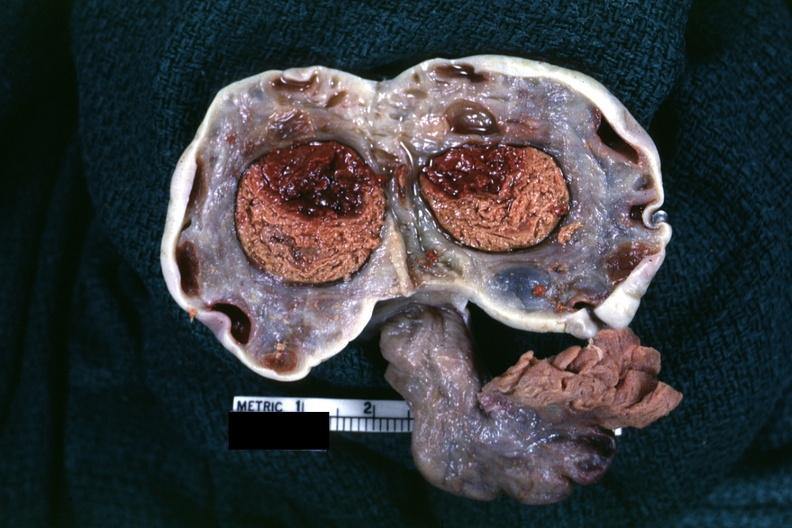what is present?
Answer the question using a single word or phrase. Female reproductive 